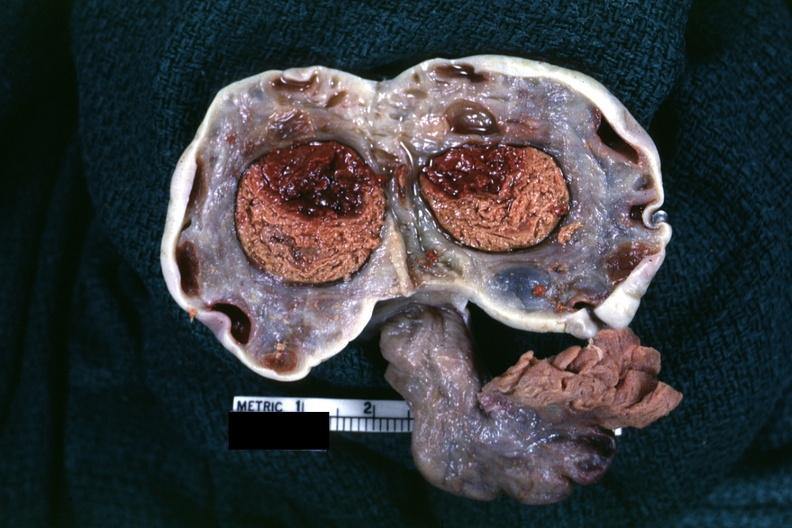what is present?
Answer the question using a single word or phrase. Female reproductive 